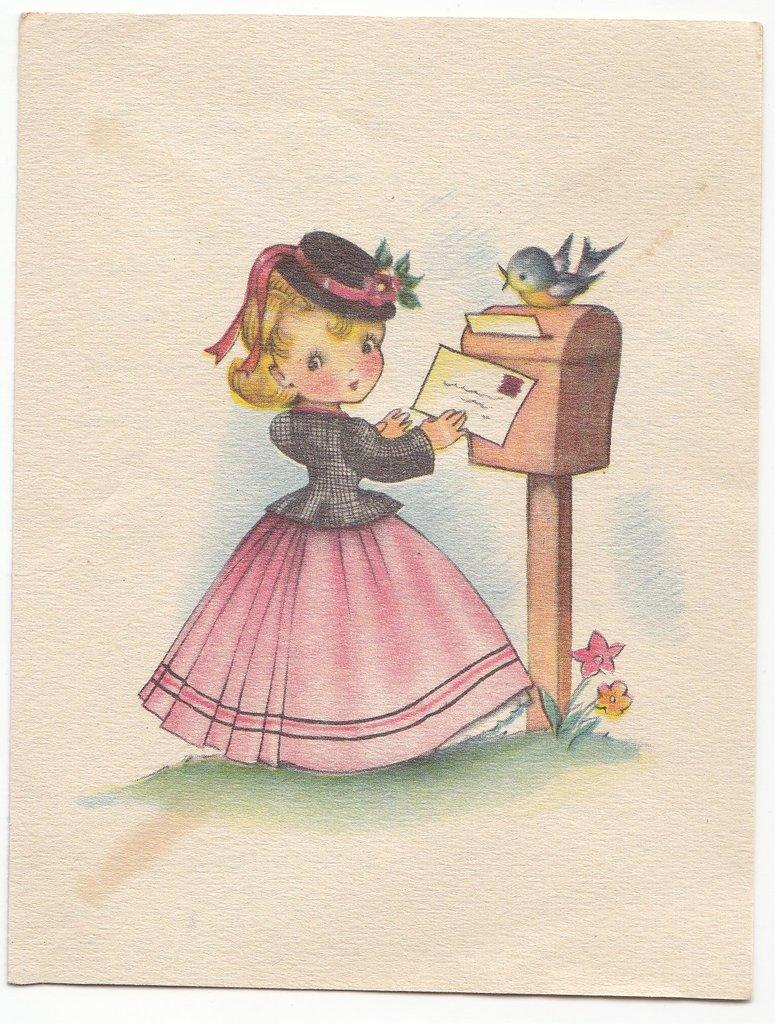What is depicted in the drawing in the image? There is a drawing of a person in the image. What else can be seen in the image besides the drawing? There are letters, a post box, flowers, and a bird in the image. What instrument does the bird play in the image? There is no instrument present in the image, and the bird is not shown playing any instrument. 